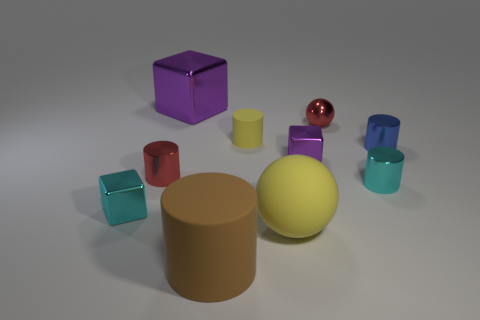Could you tell me what the lighting in this scene suggests about the setting? The soft and diffused lighting, along with the subtle shadows, indicates a controlled indoor environment, perhaps a photographic studio setup, optimized to highlight the objects' colors and textures without harsh reflections. 